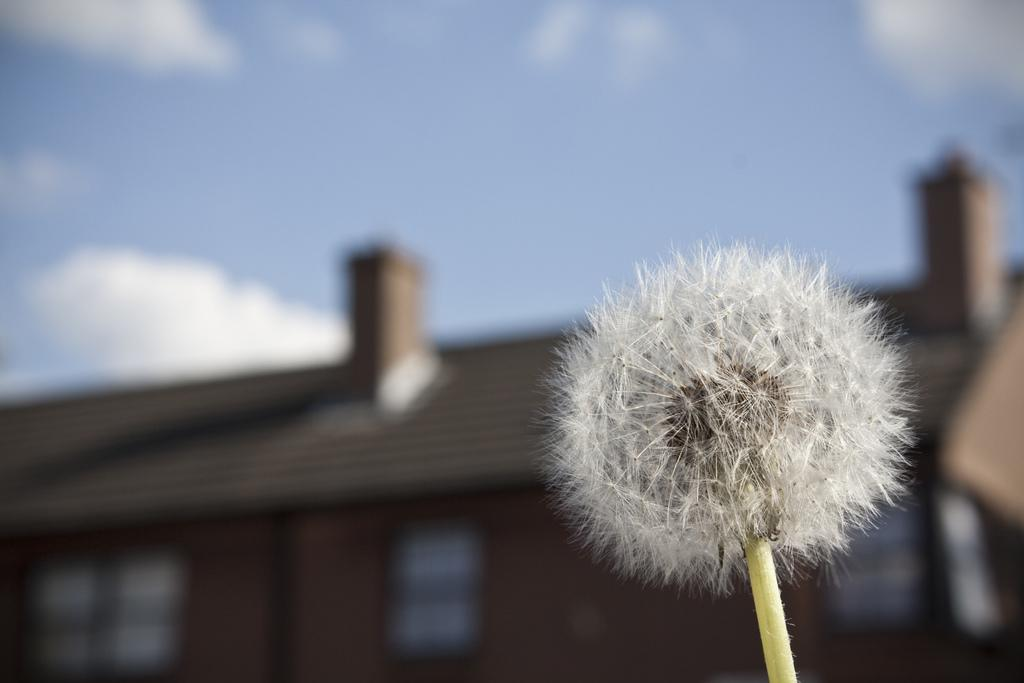What type of flower is in the image? There is a white flower in the image. Where is the flower located? The flower is attached to a tree. What is the color of the tree? The tree is green in color. What can be seen in the background of the image? There is a building and the sky visible in the background of the image. What architectural feature is present on the building? There are windows visible on the building. How many brothers are depicted in the image? There are no brothers present in the image; it features a white flower on a tree with a background of a building and the sky. What type of mint is used to decorate the tree in the image? There is no mint present in the image; it features a white flower on a green tree with a background of a building and the sky. 